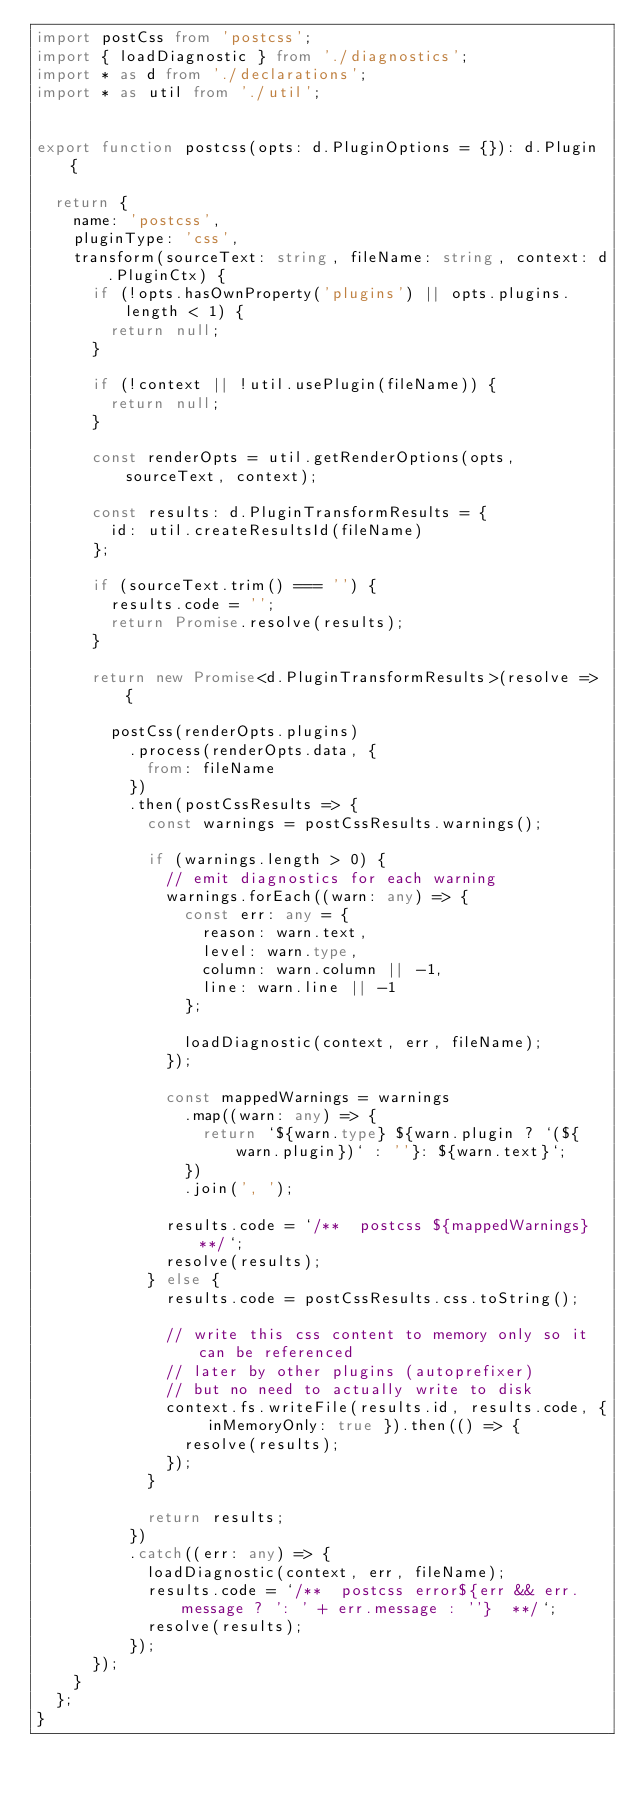<code> <loc_0><loc_0><loc_500><loc_500><_TypeScript_>import postCss from 'postcss';
import { loadDiagnostic } from './diagnostics';
import * as d from './declarations';
import * as util from './util';


export function postcss(opts: d.PluginOptions = {}): d.Plugin {

  return {
    name: 'postcss',
    pluginType: 'css',
    transform(sourceText: string, fileName: string, context: d.PluginCtx) {
      if (!opts.hasOwnProperty('plugins') || opts.plugins.length < 1) {
        return null;
      }

      if (!context || !util.usePlugin(fileName)) {
        return null;
      }

      const renderOpts = util.getRenderOptions(opts, sourceText, context);

      const results: d.PluginTransformResults = {
        id: util.createResultsId(fileName)
      };

      if (sourceText.trim() === '') {
        results.code = '';
        return Promise.resolve(results);
      }

      return new Promise<d.PluginTransformResults>(resolve => {

        postCss(renderOpts.plugins)
          .process(renderOpts.data, {
            from: fileName
          })
          .then(postCssResults => {
            const warnings = postCssResults.warnings();

            if (warnings.length > 0) {
              // emit diagnostics for each warning
              warnings.forEach((warn: any) => {
                const err: any = {
                  reason: warn.text,
                  level: warn.type,
                  column: warn.column || -1,
                  line: warn.line || -1
                };

                loadDiagnostic(context, err, fileName);
              });

              const mappedWarnings = warnings
                .map((warn: any) => {
                  return `${warn.type} ${warn.plugin ? `(${warn.plugin})` : ''}: ${warn.text}`;
                })
                .join(', ');

              results.code = `/**  postcss ${mappedWarnings}  **/`;
              resolve(results);
            } else {
              results.code = postCssResults.css.toString();

              // write this css content to memory only so it can be referenced
              // later by other plugins (autoprefixer)
              // but no need to actually write to disk
              context.fs.writeFile(results.id, results.code, { inMemoryOnly: true }).then(() => {
                resolve(results);
              });
            }

            return results;
          })
          .catch((err: any) => {
            loadDiagnostic(context, err, fileName);
            results.code = `/**  postcss error${err && err.message ? ': ' + err.message : ''}  **/`;
            resolve(results);
          });
      });
    }
  };
}
</code> 